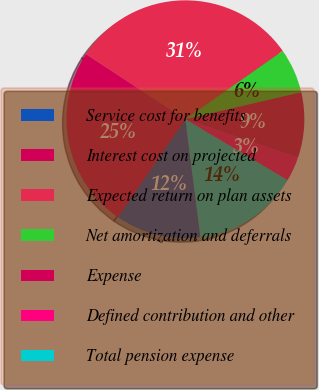Convert chart to OTSL. <chart><loc_0><loc_0><loc_500><loc_500><pie_chart><fcel>Service cost for benefits<fcel>Interest cost on projected<fcel>Expected return on plan assets<fcel>Net amortization and deferrals<fcel>Expense<fcel>Defined contribution and other<fcel>Total pension expense<nl><fcel>11.64%<fcel>24.61%<fcel>31.04%<fcel>6.1%<fcel>8.87%<fcel>3.33%<fcel>14.41%<nl></chart> 